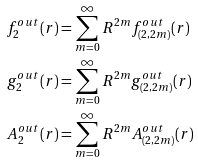<formula> <loc_0><loc_0><loc_500><loc_500>f _ { 2 } ^ { o u t } ( r ) & = \sum _ { m = 0 } ^ { \infty } R ^ { 2 m } f ^ { o u t } _ { ( 2 , 2 m ) } ( r ) \\ g _ { 2 } ^ { o u t } ( r ) & = \sum _ { m = 0 } ^ { \infty } R ^ { 2 m } g ^ { o u t } _ { ( 2 , 2 m ) } ( r ) \\ A _ { 2 } ^ { o u t } ( r ) & = \sum _ { m = 0 } ^ { \infty } R ^ { 2 m } A ^ { o u t } _ { ( 2 , 2 m ) } ( r ) \\</formula> 